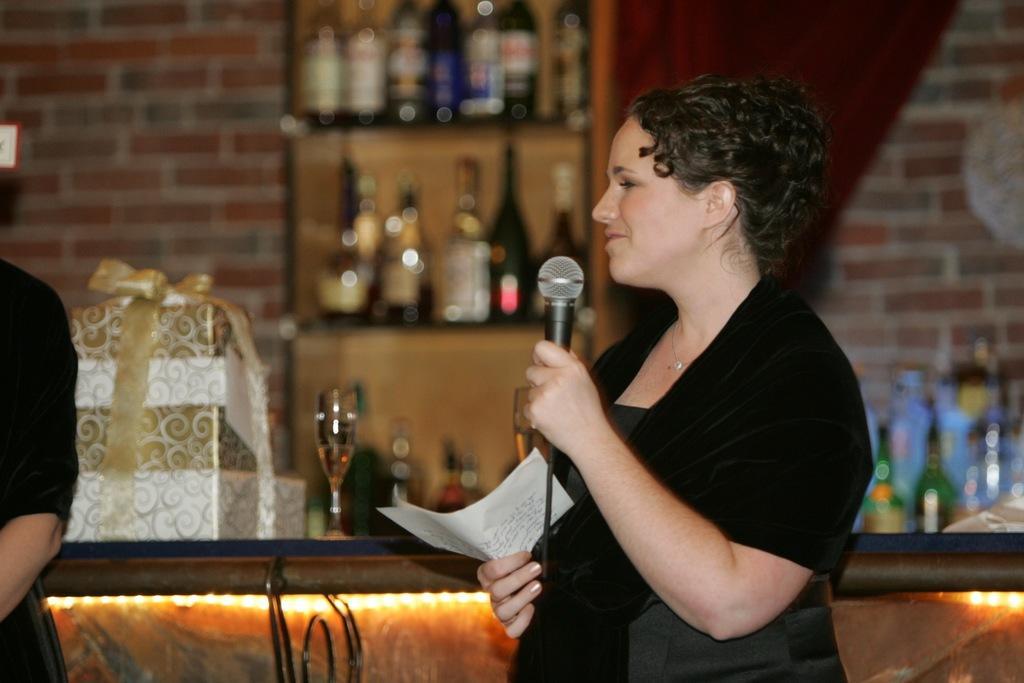Could you give a brief overview of what you see in this image? In this image I can see a woman and I can see she is wearing black dress. I can also see she is holding a mic, a white paper and on this paper I can see something is written. Here I can see one more person in black dress and in the background I can see a glass, few bottles, a gift box and I can see this image is little blurry from background. 